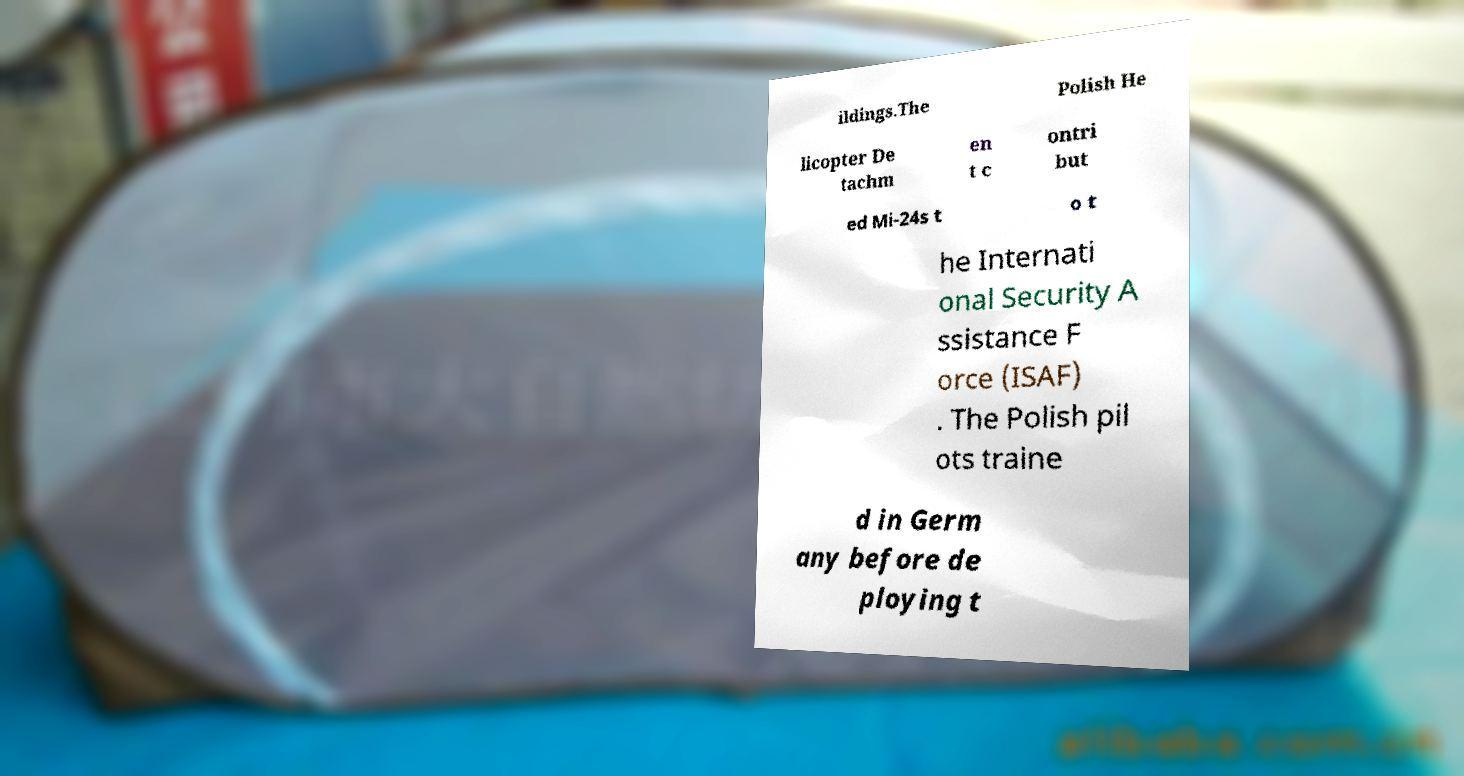Please read and relay the text visible in this image. What does it say? ildings.The Polish He licopter De tachm en t c ontri but ed Mi-24s t o t he Internati onal Security A ssistance F orce (ISAF) . The Polish pil ots traine d in Germ any before de ploying t 